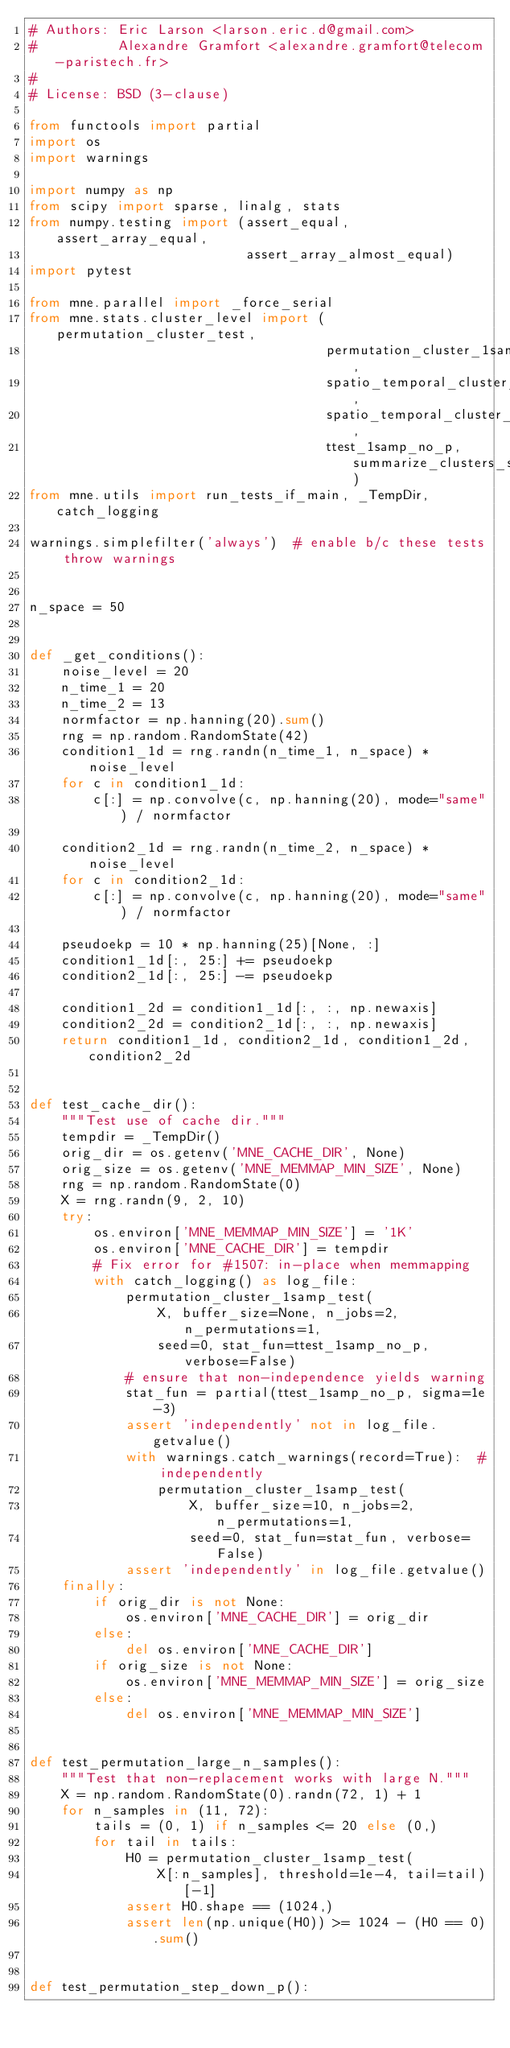<code> <loc_0><loc_0><loc_500><loc_500><_Python_># Authors: Eric Larson <larson.eric.d@gmail.com>
#          Alexandre Gramfort <alexandre.gramfort@telecom-paristech.fr>
#
# License: BSD (3-clause)

from functools import partial
import os
import warnings

import numpy as np
from scipy import sparse, linalg, stats
from numpy.testing import (assert_equal, assert_array_equal,
                           assert_array_almost_equal)
import pytest

from mne.parallel import _force_serial
from mne.stats.cluster_level import (permutation_cluster_test,
                                     permutation_cluster_1samp_test,
                                     spatio_temporal_cluster_test,
                                     spatio_temporal_cluster_1samp_test,
                                     ttest_1samp_no_p, summarize_clusters_stc)
from mne.utils import run_tests_if_main, _TempDir, catch_logging

warnings.simplefilter('always')  # enable b/c these tests throw warnings


n_space = 50


def _get_conditions():
    noise_level = 20
    n_time_1 = 20
    n_time_2 = 13
    normfactor = np.hanning(20).sum()
    rng = np.random.RandomState(42)
    condition1_1d = rng.randn(n_time_1, n_space) * noise_level
    for c in condition1_1d:
        c[:] = np.convolve(c, np.hanning(20), mode="same") / normfactor

    condition2_1d = rng.randn(n_time_2, n_space) * noise_level
    for c in condition2_1d:
        c[:] = np.convolve(c, np.hanning(20), mode="same") / normfactor

    pseudoekp = 10 * np.hanning(25)[None, :]
    condition1_1d[:, 25:] += pseudoekp
    condition2_1d[:, 25:] -= pseudoekp

    condition1_2d = condition1_1d[:, :, np.newaxis]
    condition2_2d = condition2_1d[:, :, np.newaxis]
    return condition1_1d, condition2_1d, condition1_2d, condition2_2d


def test_cache_dir():
    """Test use of cache dir."""
    tempdir = _TempDir()
    orig_dir = os.getenv('MNE_CACHE_DIR', None)
    orig_size = os.getenv('MNE_MEMMAP_MIN_SIZE', None)
    rng = np.random.RandomState(0)
    X = rng.randn(9, 2, 10)
    try:
        os.environ['MNE_MEMMAP_MIN_SIZE'] = '1K'
        os.environ['MNE_CACHE_DIR'] = tempdir
        # Fix error for #1507: in-place when memmapping
        with catch_logging() as log_file:
            permutation_cluster_1samp_test(
                X, buffer_size=None, n_jobs=2, n_permutations=1,
                seed=0, stat_fun=ttest_1samp_no_p, verbose=False)
            # ensure that non-independence yields warning
            stat_fun = partial(ttest_1samp_no_p, sigma=1e-3)
            assert 'independently' not in log_file.getvalue()
            with warnings.catch_warnings(record=True):  # independently
                permutation_cluster_1samp_test(
                    X, buffer_size=10, n_jobs=2, n_permutations=1,
                    seed=0, stat_fun=stat_fun, verbose=False)
            assert 'independently' in log_file.getvalue()
    finally:
        if orig_dir is not None:
            os.environ['MNE_CACHE_DIR'] = orig_dir
        else:
            del os.environ['MNE_CACHE_DIR']
        if orig_size is not None:
            os.environ['MNE_MEMMAP_MIN_SIZE'] = orig_size
        else:
            del os.environ['MNE_MEMMAP_MIN_SIZE']


def test_permutation_large_n_samples():
    """Test that non-replacement works with large N."""
    X = np.random.RandomState(0).randn(72, 1) + 1
    for n_samples in (11, 72):
        tails = (0, 1) if n_samples <= 20 else (0,)
        for tail in tails:
            H0 = permutation_cluster_1samp_test(
                X[:n_samples], threshold=1e-4, tail=tail)[-1]
            assert H0.shape == (1024,)
            assert len(np.unique(H0)) >= 1024 - (H0 == 0).sum()


def test_permutation_step_down_p():</code> 